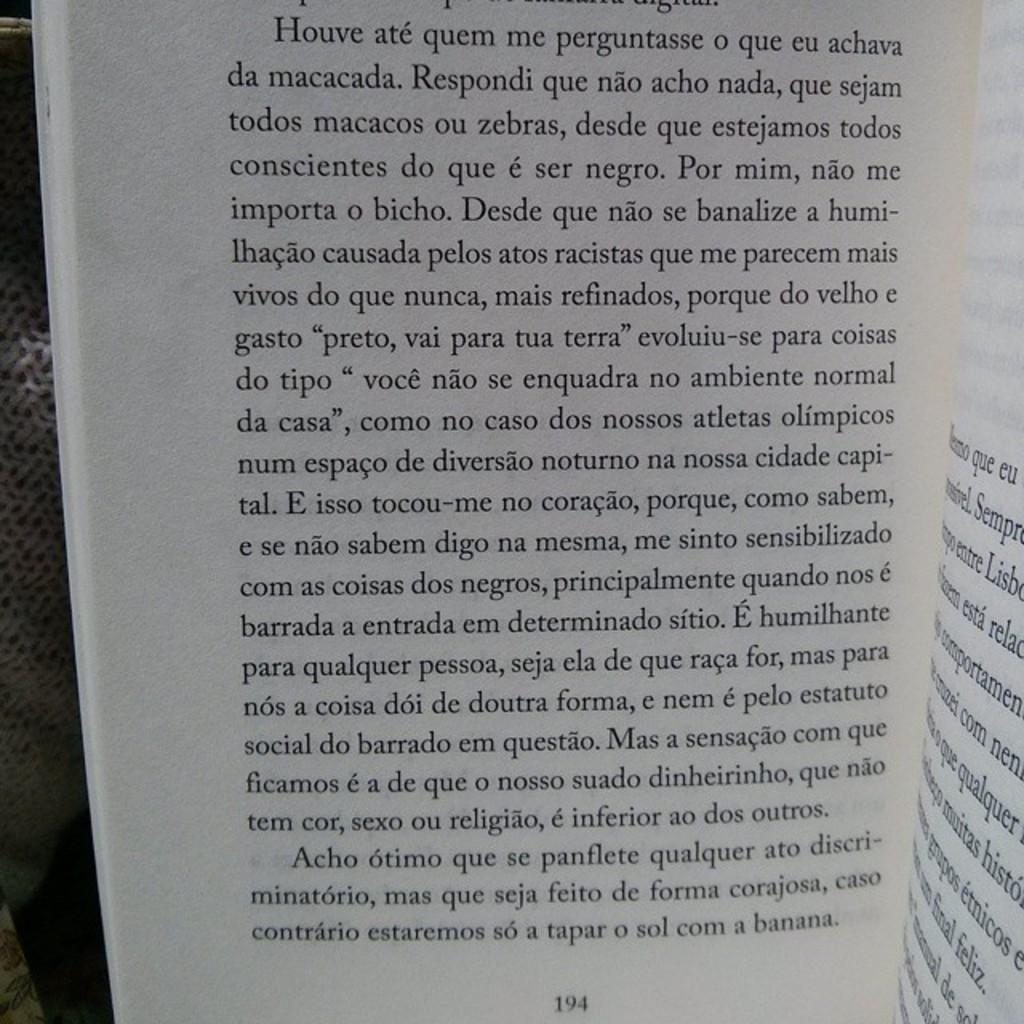<image>
Write a terse but informative summary of the picture. Page 194 of a book written in a different language 